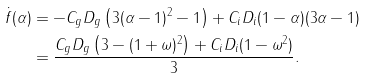<formula> <loc_0><loc_0><loc_500><loc_500>\dot { f } ( \alpha ) & = - C _ { g } D _ { g } \left ( 3 ( \alpha - 1 ) ^ { 2 } - 1 \right ) + C _ { i } D _ { i } ( 1 - \alpha ) ( 3 \alpha - 1 ) \\ & = \frac { C _ { g } D _ { g } \left ( 3 - ( 1 + \omega ) ^ { 2 } \right ) + C _ { i } D _ { i } ( 1 - \omega ^ { 2 } ) } { 3 } .</formula> 